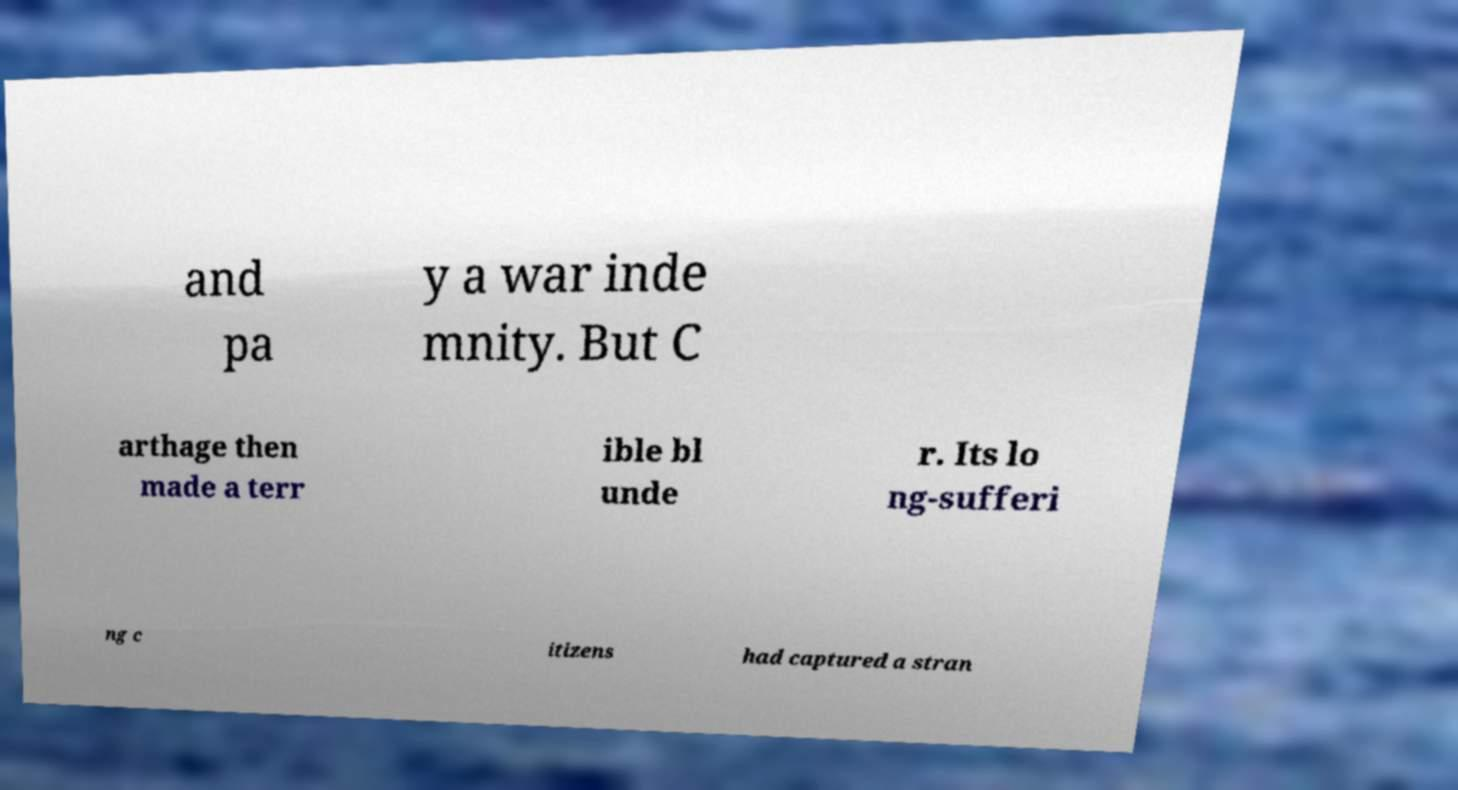Could you assist in decoding the text presented in this image and type it out clearly? and pa y a war inde mnity. But C arthage then made a terr ible bl unde r. Its lo ng-sufferi ng c itizens had captured a stran 